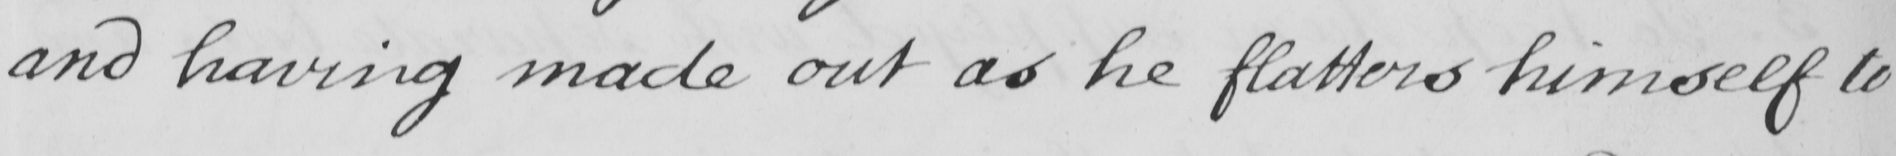What text is written in this handwritten line? and having made out as he flatters himself to 